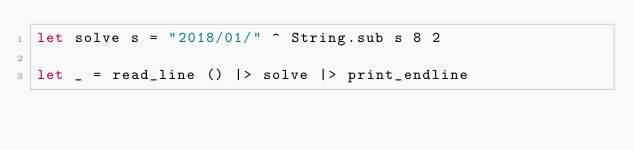<code> <loc_0><loc_0><loc_500><loc_500><_OCaml_>let solve s = "2018/01/" ^ String.sub s 8 2

let _ = read_line () |> solve |> print_endline</code> 